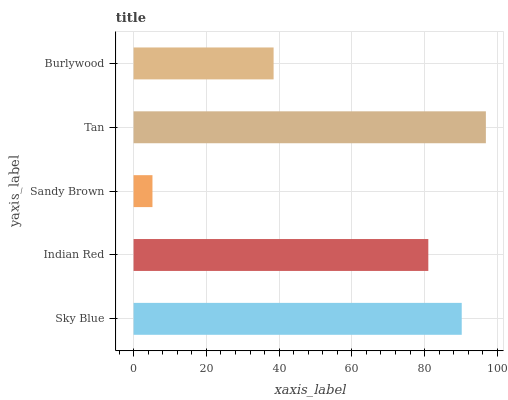Is Sandy Brown the minimum?
Answer yes or no. Yes. Is Tan the maximum?
Answer yes or no. Yes. Is Indian Red the minimum?
Answer yes or no. No. Is Indian Red the maximum?
Answer yes or no. No. Is Sky Blue greater than Indian Red?
Answer yes or no. Yes. Is Indian Red less than Sky Blue?
Answer yes or no. Yes. Is Indian Red greater than Sky Blue?
Answer yes or no. No. Is Sky Blue less than Indian Red?
Answer yes or no. No. Is Indian Red the high median?
Answer yes or no. Yes. Is Indian Red the low median?
Answer yes or no. Yes. Is Burlywood the high median?
Answer yes or no. No. Is Sandy Brown the low median?
Answer yes or no. No. 